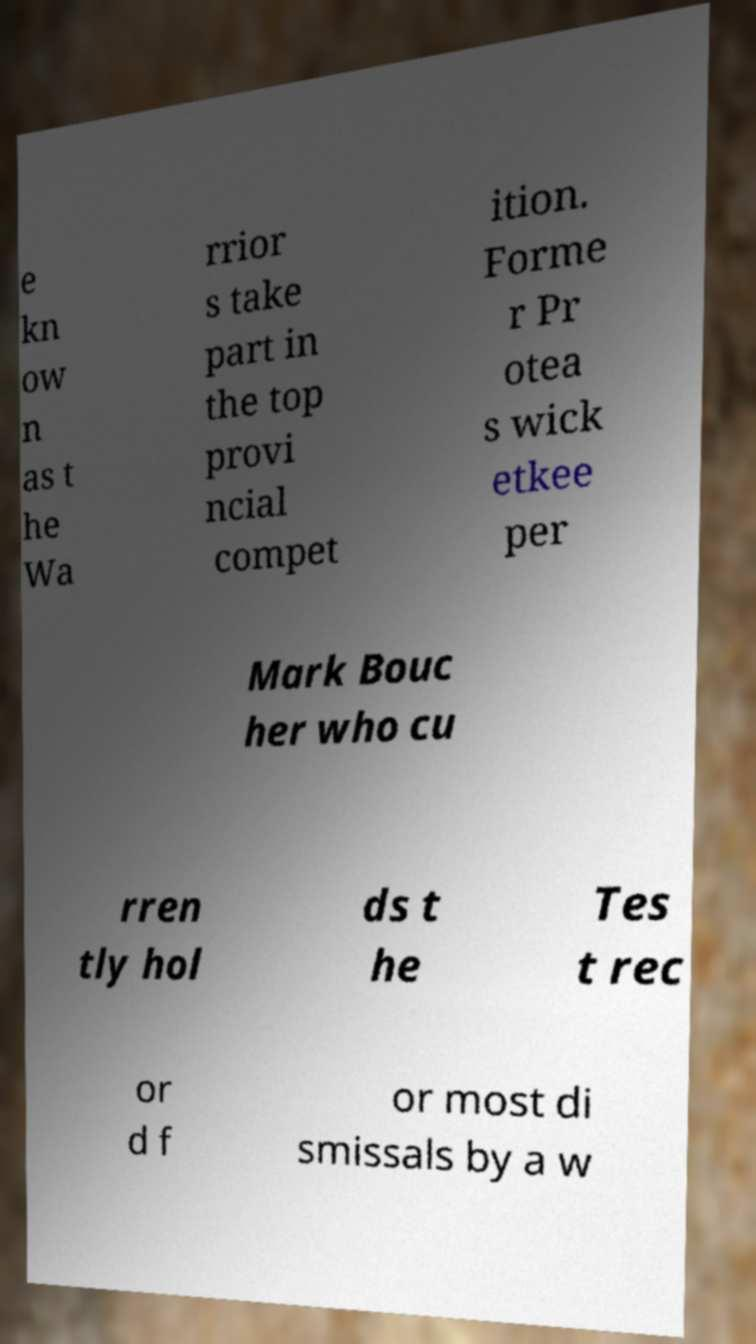Can you read and provide the text displayed in the image?This photo seems to have some interesting text. Can you extract and type it out for me? e kn ow n as t he Wa rrior s take part in the top provi ncial compet ition. Forme r Pr otea s wick etkee per Mark Bouc her who cu rren tly hol ds t he Tes t rec or d f or most di smissals by a w 